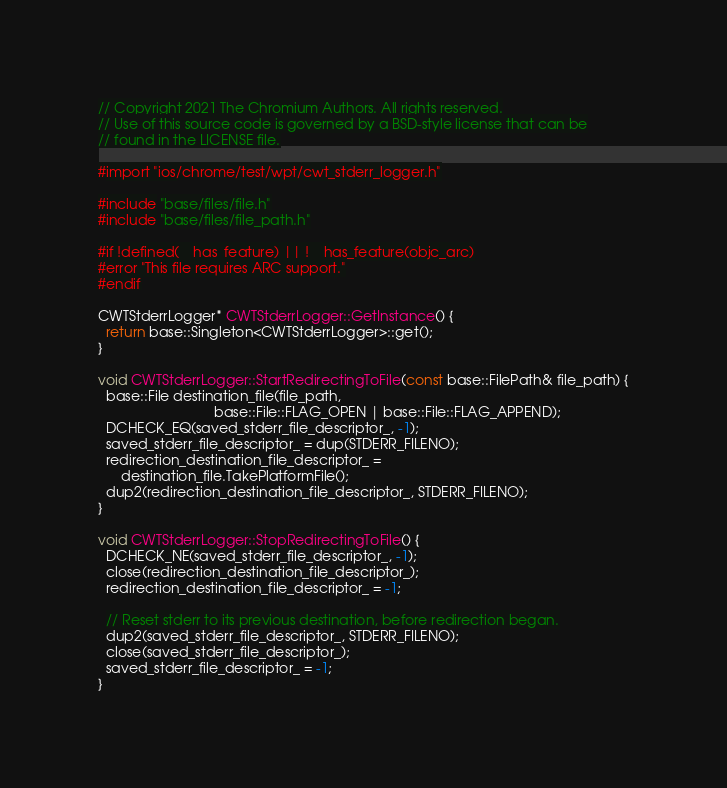Convert code to text. <code><loc_0><loc_0><loc_500><loc_500><_ObjectiveC_>// Copyright 2021 The Chromium Authors. All rights reserved.
// Use of this source code is governed by a BSD-style license that can be
// found in the LICENSE file.

#import "ios/chrome/test/wpt/cwt_stderr_logger.h"

#include "base/files/file.h"
#include "base/files/file_path.h"

#if !defined(__has_feature) || !__has_feature(objc_arc)
#error "This file requires ARC support."
#endif

CWTStderrLogger* CWTStderrLogger::GetInstance() {
  return base::Singleton<CWTStderrLogger>::get();
}

void CWTStderrLogger::StartRedirectingToFile(const base::FilePath& file_path) {
  base::File destination_file(file_path,
                              base::File::FLAG_OPEN | base::File::FLAG_APPEND);
  DCHECK_EQ(saved_stderr_file_descriptor_, -1);
  saved_stderr_file_descriptor_ = dup(STDERR_FILENO);
  redirection_destination_file_descriptor_ =
      destination_file.TakePlatformFile();
  dup2(redirection_destination_file_descriptor_, STDERR_FILENO);
}

void CWTStderrLogger::StopRedirectingToFile() {
  DCHECK_NE(saved_stderr_file_descriptor_, -1);
  close(redirection_destination_file_descriptor_);
  redirection_destination_file_descriptor_ = -1;

  // Reset stderr to its previous destination, before redirection began.
  dup2(saved_stderr_file_descriptor_, STDERR_FILENO);
  close(saved_stderr_file_descriptor_);
  saved_stderr_file_descriptor_ = -1;
}
</code> 